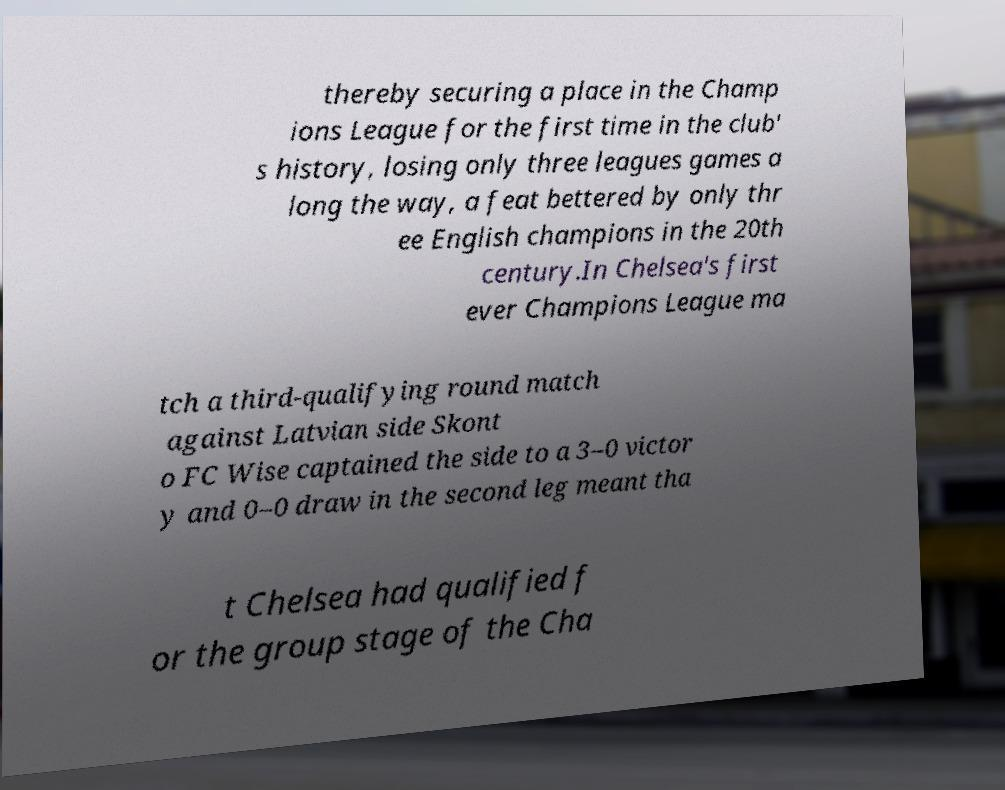Could you assist in decoding the text presented in this image and type it out clearly? thereby securing a place in the Champ ions League for the first time in the club' s history, losing only three leagues games a long the way, a feat bettered by only thr ee English champions in the 20th century.In Chelsea's first ever Champions League ma tch a third-qualifying round match against Latvian side Skont o FC Wise captained the side to a 3–0 victor y and 0–0 draw in the second leg meant tha t Chelsea had qualified f or the group stage of the Cha 